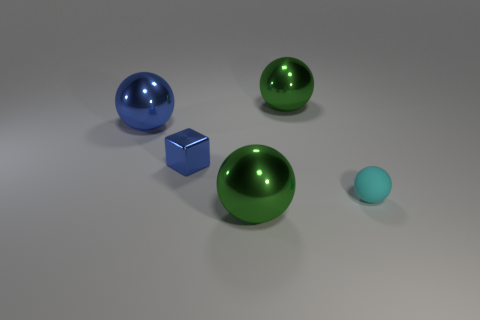How many other objects are the same material as the tiny ball? Upon analyzing the image, it appears that the tiny ball is made of a matte material, distinguishing it from the other objects that exhibit reflective properties. Therefore, there are no other objects in the image made of the same material as the tiny ball. 